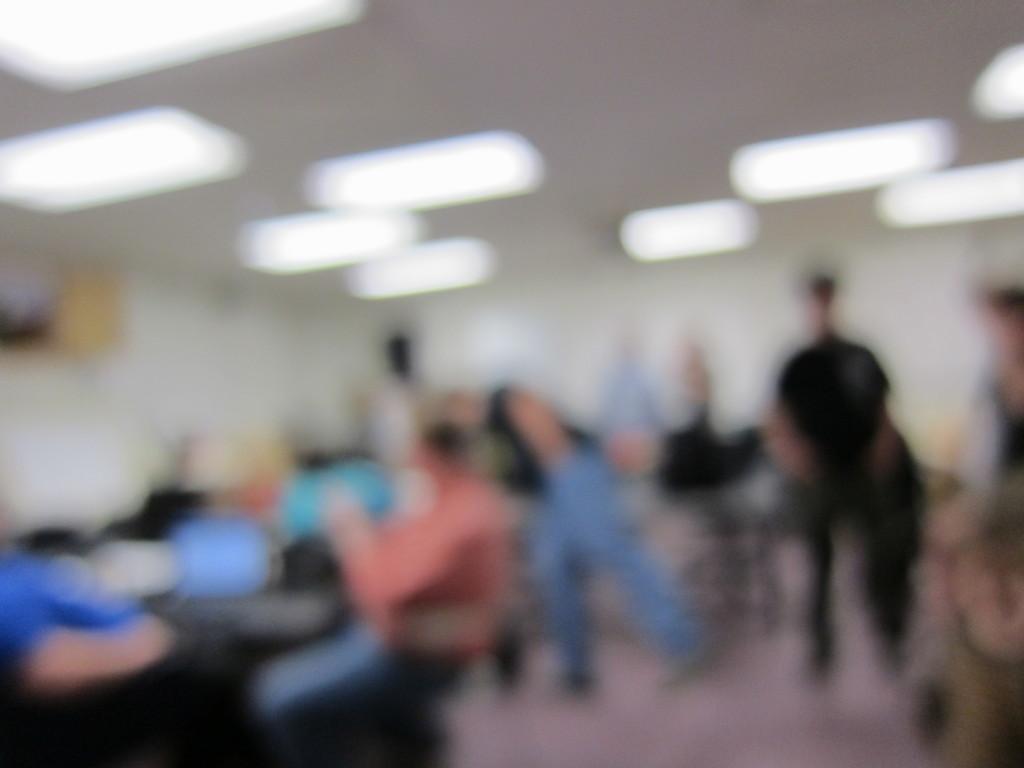Can you describe this image briefly? This is a blur image. In this image few people are visible. At the top there are some lights. 